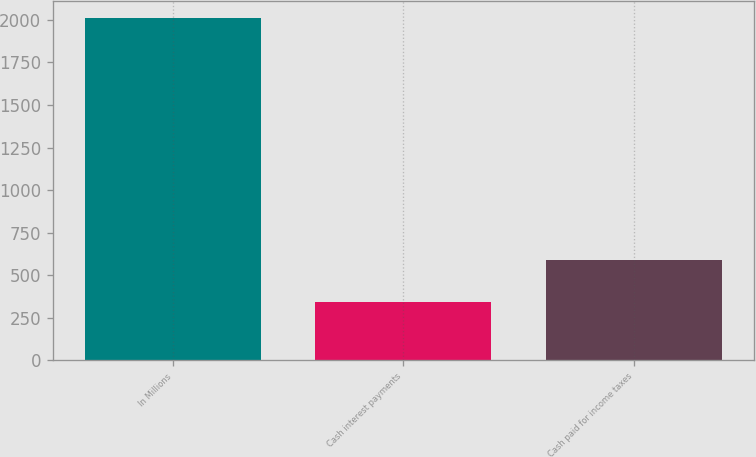<chart> <loc_0><loc_0><loc_500><loc_500><bar_chart><fcel>In Millions<fcel>Cash interest payments<fcel>Cash paid for income taxes<nl><fcel>2012<fcel>344.3<fcel>590.6<nl></chart> 